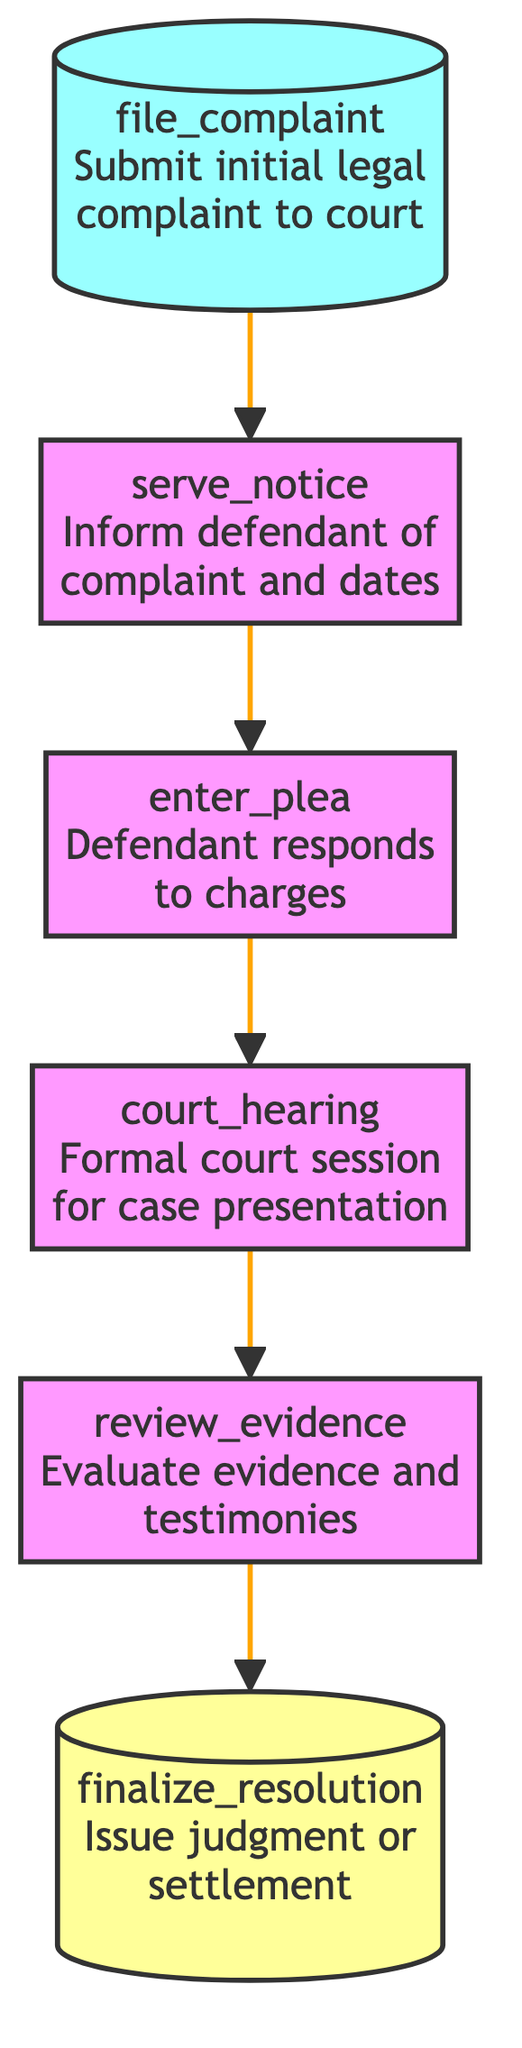What is the first step in addressing a legal complaint? The diagram shows that the first step is to "file_complaint," which involves submitting the initial legal complaint to the court.
Answer: file_complaint Which step follows "serve_notice"? From the diagram, the step that comes after "serve_notice" is "enter_plea." This indicates the sequence in the flow of the legal process.
Answer: enter_plea How many steps are there in the process? By counting the nodes in the diagram (file_complaint, serve_notice, enter_plea, court_hearing, review_evidence, finalize_resolution), there are a total of six steps in the legal complaint process.
Answer: 6 What is the last step in the procedure? According to the diagram, the last step is "finalize_resolution," which concludes the legal process by issuing a judgment or settlement.
Answer: finalize_resolution What does the defendant respond with during the "enter_plea" step? The "enter_plea" step indicates that the defendant responds to the charges with a plea, specifically of guilty, not guilty, or no contest.
Answer: guilty, not guilty, or no contest Which step involves evaluating evidence? The diagram specifies that "review_evidence" is the step that involves evaluating all presented evidence and witness testimonies, making it clear in the flow.
Answer: review_evidence What is the relationship between "court_hearing" and "review_evidence"? The diagram illustrates a direct flow where "court_hearing" leads to "review_evidence," indicating that after the hearing, evidence is evaluated.
Answer: court_hearing leads to review_evidence What is the purpose of the "serve_notice" step? The "serve_notice" step serves the purpose of officially informing the defendant of the legal complaint and court dates, as shown in the description.
Answer: Inform defendant of complaint and dates 